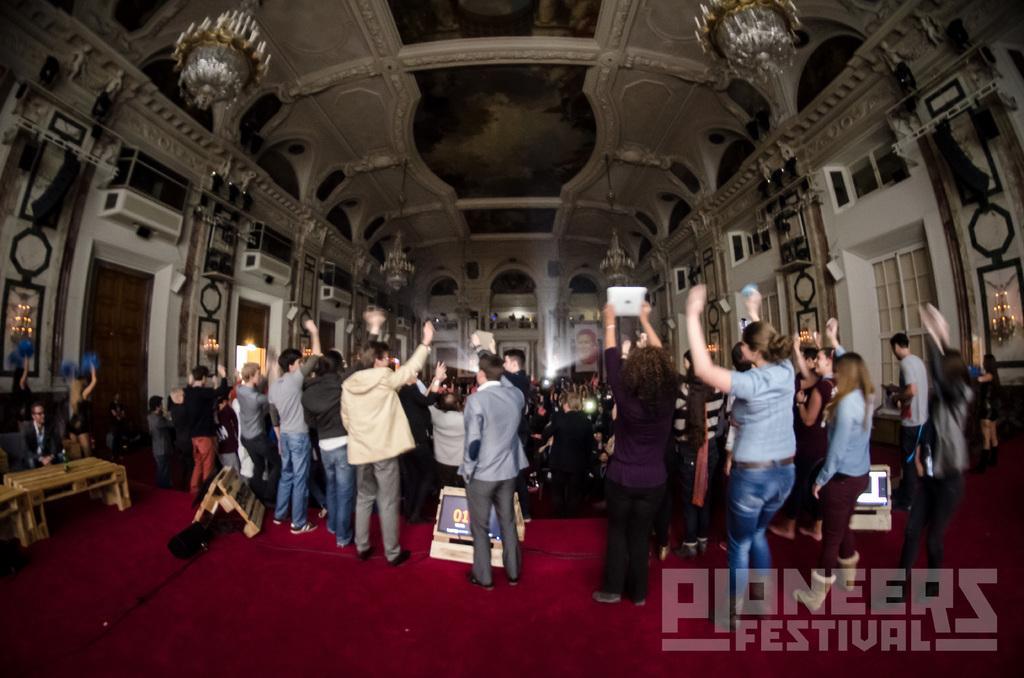Can you describe this image briefly? In this image we can see a few people, some of them are standing, one of them is holding a tab, there is an object on the table, there are boards with text on them, there are some lights on the walls, there are air conditioners, there are chandeliers, windows, also we can see a photo frame of a person, and there is text on the image. 